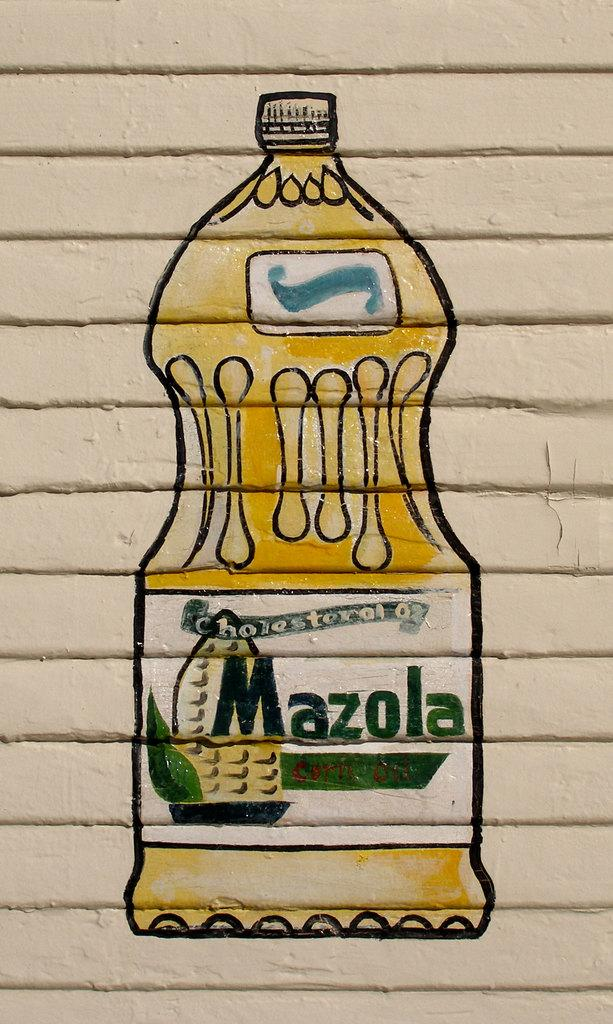<image>
Share a concise interpretation of the image provided. a drawing of a bottle of oil with Mazola on it 